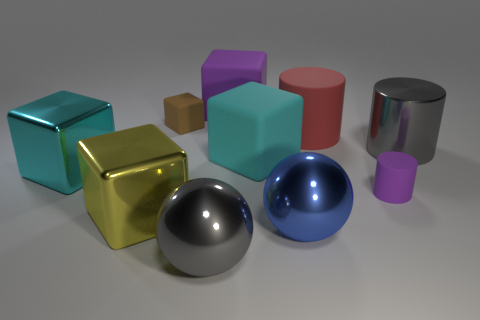Subtract all purple cubes. How many cubes are left? 4 Subtract all small cubes. How many cubes are left? 4 Subtract all blue blocks. Subtract all yellow cylinders. How many blocks are left? 5 Subtract all balls. How many objects are left? 8 Subtract 0 brown cylinders. How many objects are left? 10 Subtract all big yellow cylinders. Subtract all purple blocks. How many objects are left? 9 Add 6 large gray cylinders. How many large gray cylinders are left? 7 Add 5 big purple metallic cylinders. How many big purple metallic cylinders exist? 5 